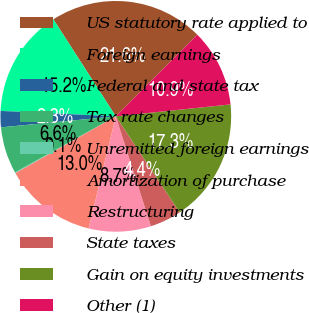Convert chart. <chart><loc_0><loc_0><loc_500><loc_500><pie_chart><fcel>US statutory rate applied to<fcel>Foreign earnings<fcel>Federal and state tax<fcel>Tax rate changes<fcel>Unremitted foreign earnings<fcel>Amortization of purchase<fcel>Restructuring<fcel>State taxes<fcel>Gain on equity investments<fcel>Other (1)<nl><fcel>21.59%<fcel>15.15%<fcel>2.27%<fcel>6.56%<fcel>0.12%<fcel>13.01%<fcel>8.71%<fcel>4.42%<fcel>17.3%<fcel>10.86%<nl></chart> 